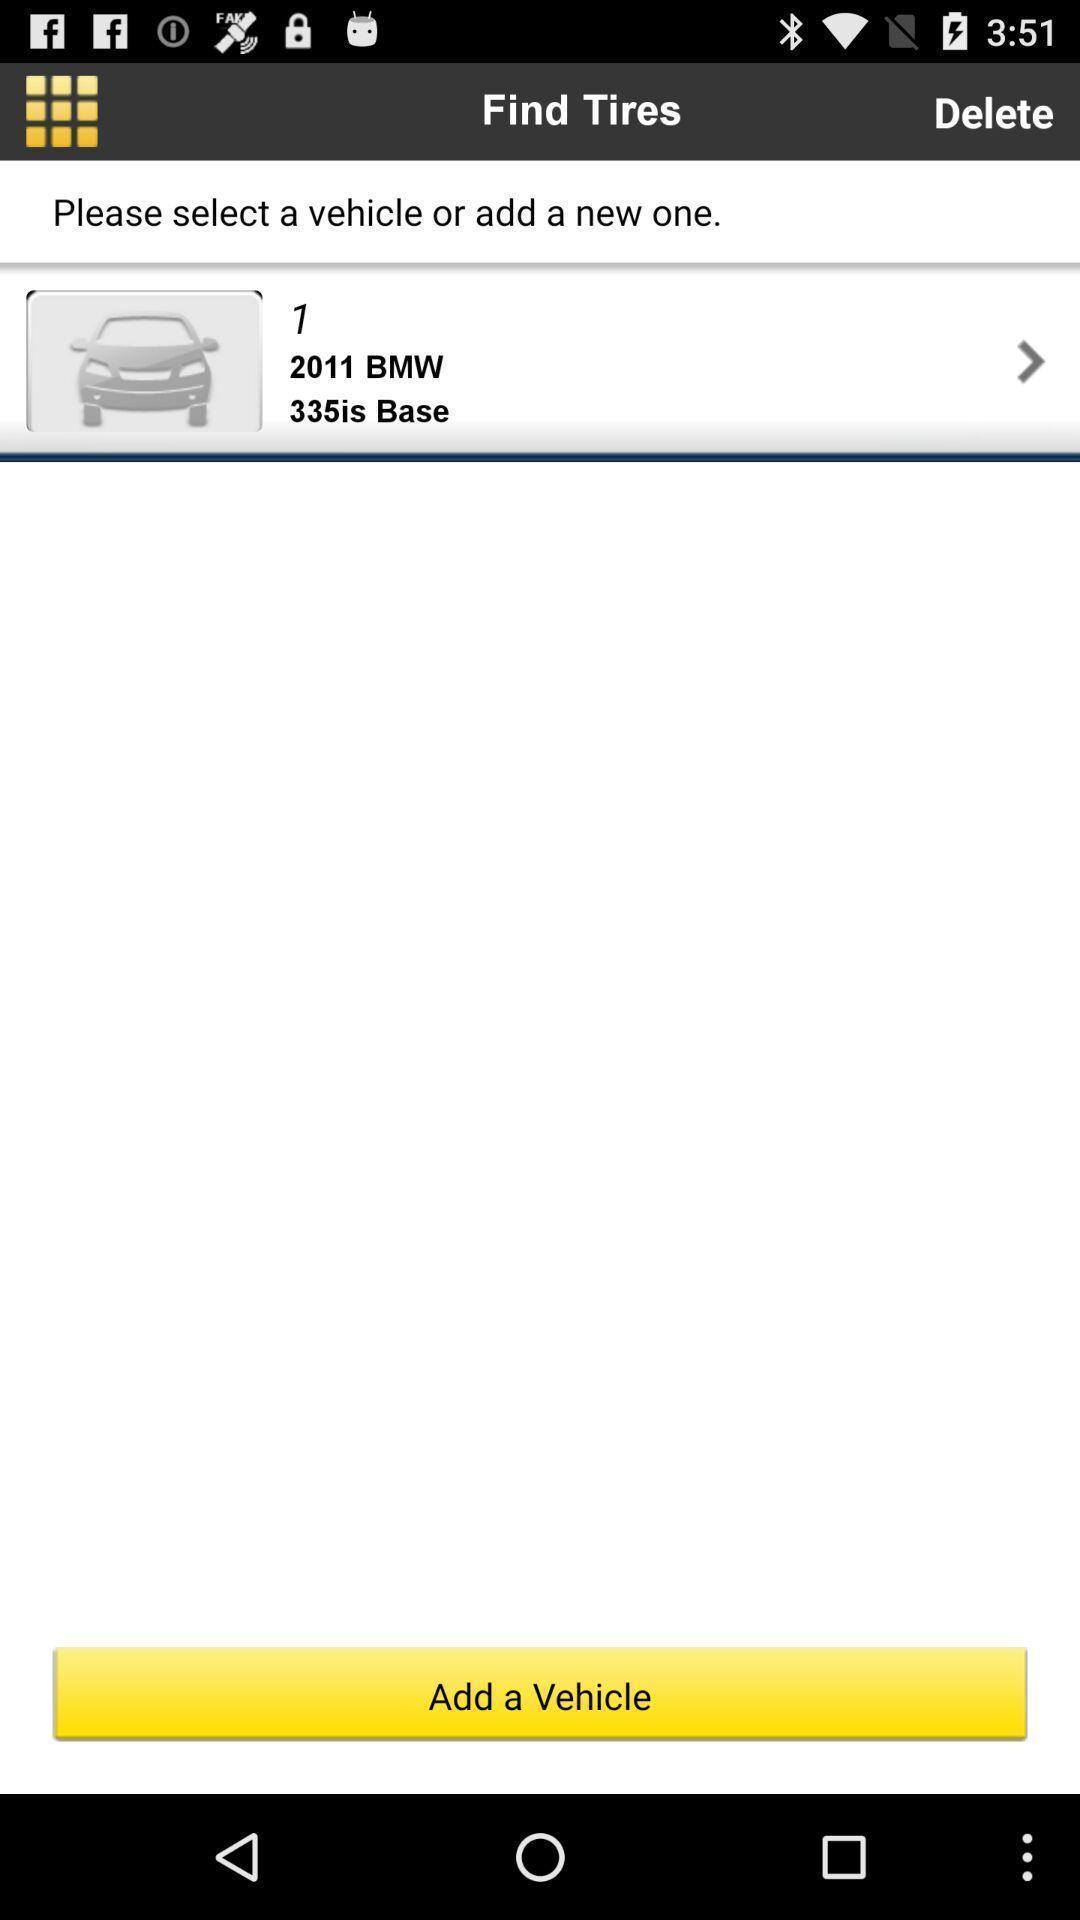What details can you identify in this image? Screen page displaying to select an option. 